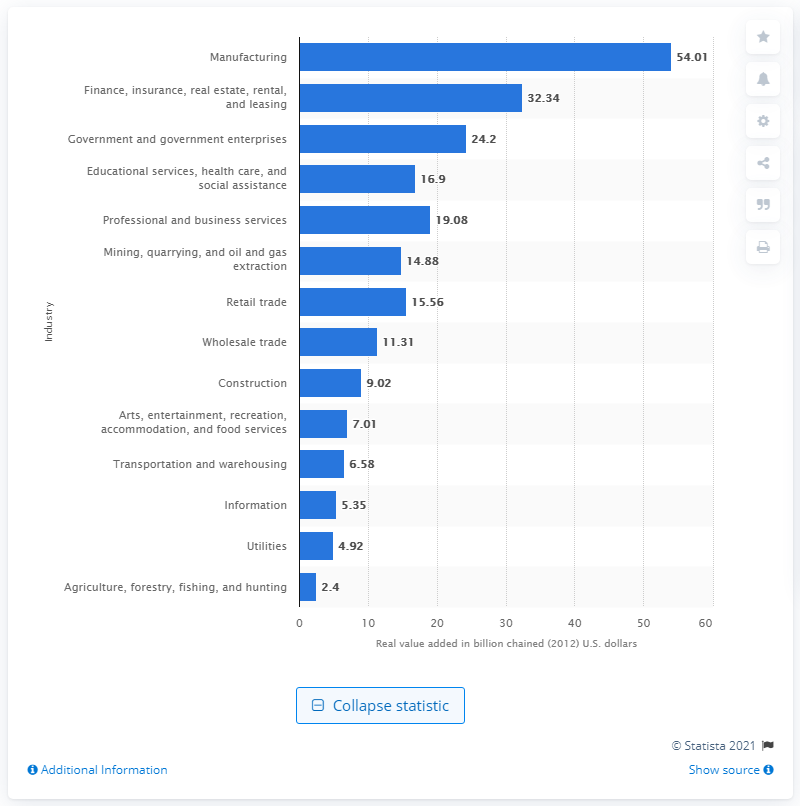Point out several critical features in this image. In 2012, the manufacturing industry contributed a significant amount to Louisiana's Gross Domestic Product, with a total contribution of $54.01. 